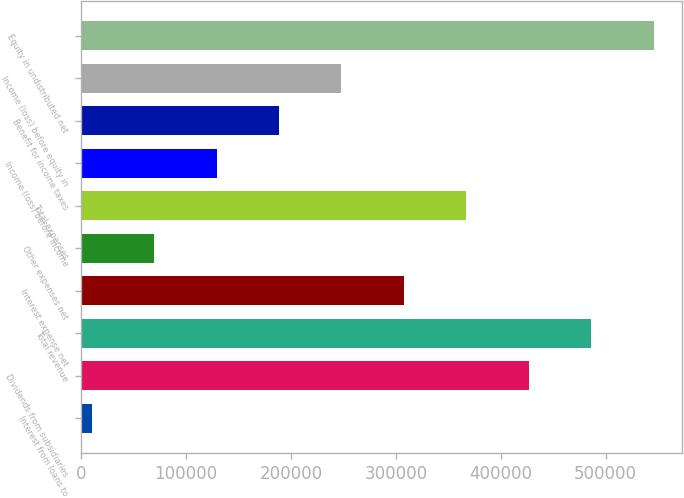<chart> <loc_0><loc_0><loc_500><loc_500><bar_chart><fcel>Interest from loans to<fcel>Dividends from subsidiaries<fcel>Total revenue<fcel>Interest expense net<fcel>Other expenses net<fcel>Total expenses<fcel>Income (loss) before income<fcel>Benefit for income taxes<fcel>Income (loss) before equity in<fcel>Equity in undistributed net<nl><fcel>9986<fcel>426795<fcel>486340<fcel>307707<fcel>69530.2<fcel>367251<fcel>129074<fcel>188619<fcel>248163<fcel>545884<nl></chart> 